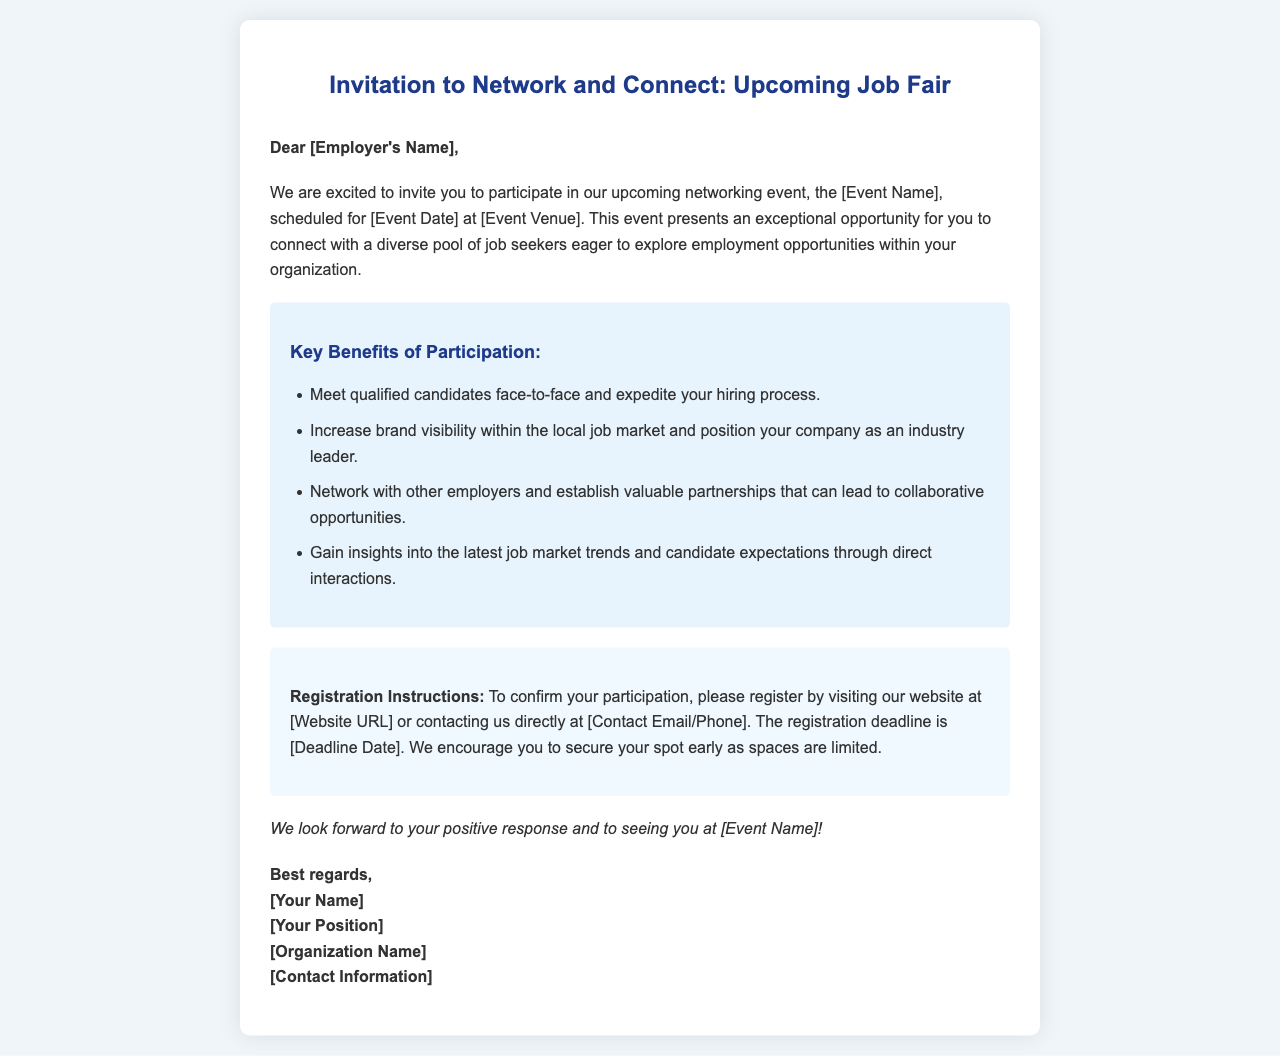What is the name of the event? The event is referred to as [Event Name] in the document, but the specific name is not provided.
Answer: [Event Name] When is the event scheduled? The event date is mentioned as [Event Date], but the specific date is not provided.
Answer: [Event Date] What is one key benefit of participation? The document lists several benefits; one of them is meeting qualified candidates face-to-face.
Answer: Meet qualified candidates face-to-face How can employers register for the event? The registration details indicate that employers can register by visiting a website or contacting directly.
Answer: Visiting our website or contacting us directly What is the deadline for registration? The registration deadline is mentioned as [Deadline Date], but the specific date is not detailed.
Answer: [Deadline Date] Who is the sender of the invitation? The document features a signature section with placeholders for sender details, including [Your Name].
Answer: [Your Name] What color is used for the heading? The heading of the document is styled with a specific color.
Answer: #1e3a8a How is the content structured? The document is organized into distinct sections such as salutation, content, benefits, and registration.
Answer: Distinct sections What type of document is this? The purpose and format indicate that this is an invitation letter.
Answer: Invitation letter 